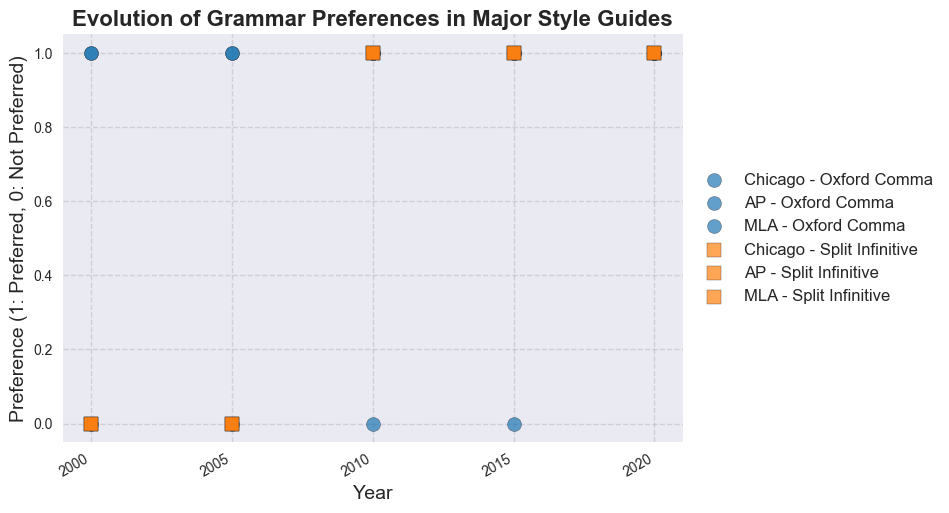What is the trend in the Chicago style guide's preference for the Oxford comma from 2000 to 2020? The Chicago style guide consistently prefers the Oxford comma from 2000 to 2020, as represented by markers at 1 across all years.
Answer: Consistent preference How did AP's preference for the Oxford comma change from 2000 to 2020? AP's preference for the Oxford comma changed in 2020. From 2000 to 2015, the preference was 0 (Not Preferred), but in 2020 it moved to 1 (Preferred).
Answer: Changed to Preferred in 2020 Which style guide first allowed the split infinitive? In 2010, all three style guides (Chicago, AP, and MLA) changed their preference to allow split infinitives.
Answer: All three in 2010 What was the overall trend for MLA's preference regarding the Oxford comma? MLA consistently preferred the Oxford comma from 2000 to 2020, as indicated by markers at 1 across all years.
Answer: Consistent preference Between 2000 and 2010, how many times did Chicago change its preference for the split infinitive? Chicago changed its preference for the split infinitive once, from not preferred (0) in 2005 to preferred (1) in 2010.
Answer: Once In 2005, what was the preference for the split infinitive across all style guides? In 2005, all three style guides (Chicago, AP, and MLA) did not prefer split infinitives, as represented by markers at 0.
Answer: Not preferred Compare the Oxford comma preference in 2005 between MLA and AP. MLA preferred the Oxford comma (1), while AP did not (0) in 2005.
Answer: MLA preferred, AP did not What visual change is noticeable in AP’s preference for Oxford commas between 2015 and 2020? A visual change from marker at 0 to 1, indicating that AP changed its preference to favor the Oxford comma in 2020, is noticeable.
Answer: Changed to preferred in 2020 